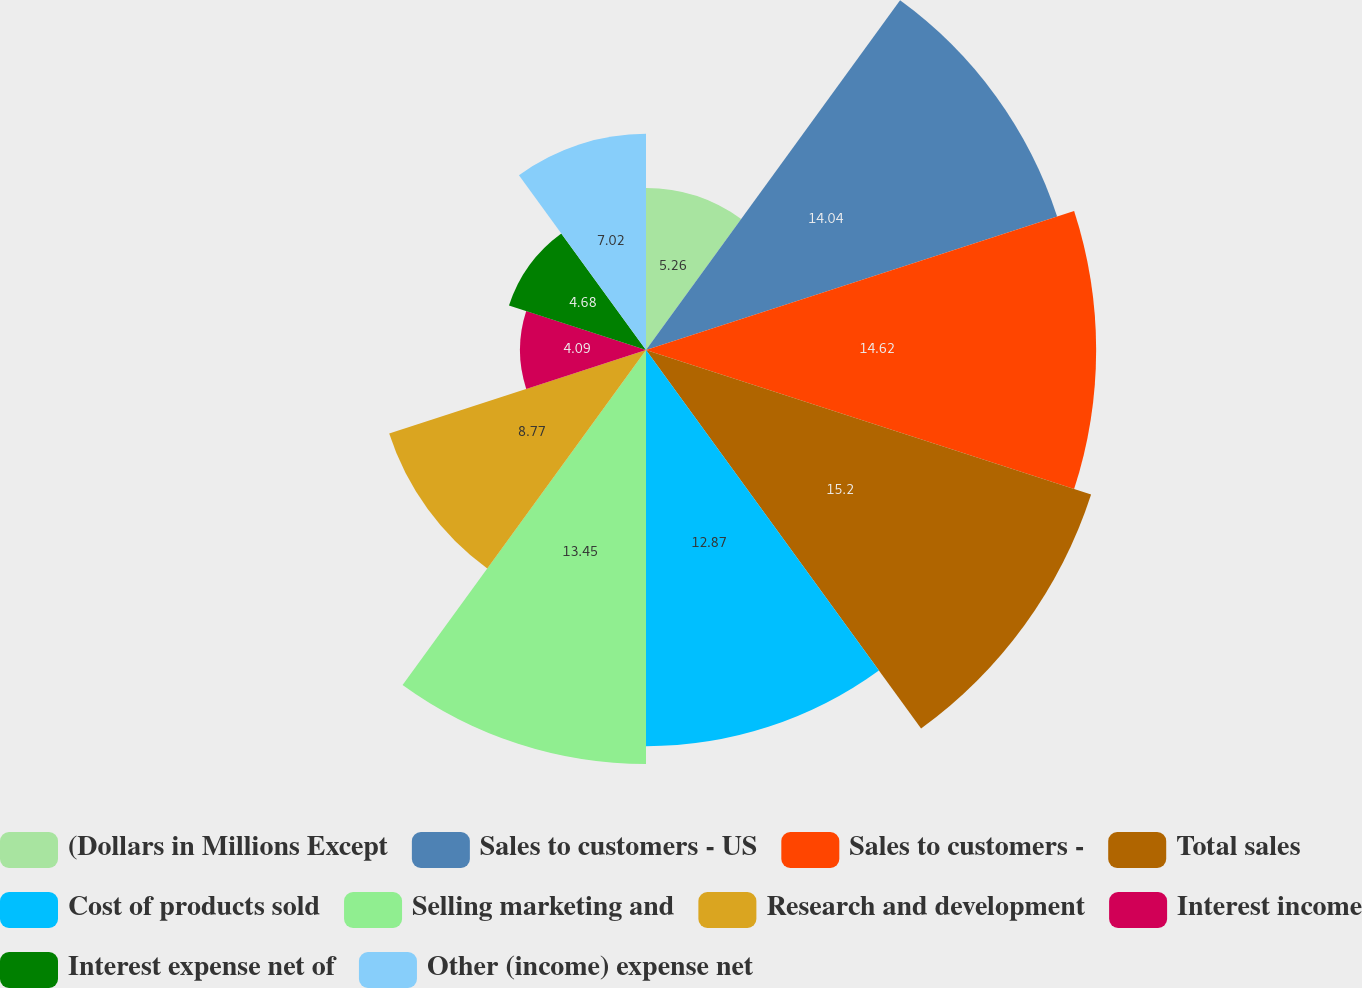<chart> <loc_0><loc_0><loc_500><loc_500><pie_chart><fcel>(Dollars in Millions Except<fcel>Sales to customers - US<fcel>Sales to customers -<fcel>Total sales<fcel>Cost of products sold<fcel>Selling marketing and<fcel>Research and development<fcel>Interest income<fcel>Interest expense net of<fcel>Other (income) expense net<nl><fcel>5.26%<fcel>14.04%<fcel>14.62%<fcel>15.2%<fcel>12.87%<fcel>13.45%<fcel>8.77%<fcel>4.09%<fcel>4.68%<fcel>7.02%<nl></chart> 